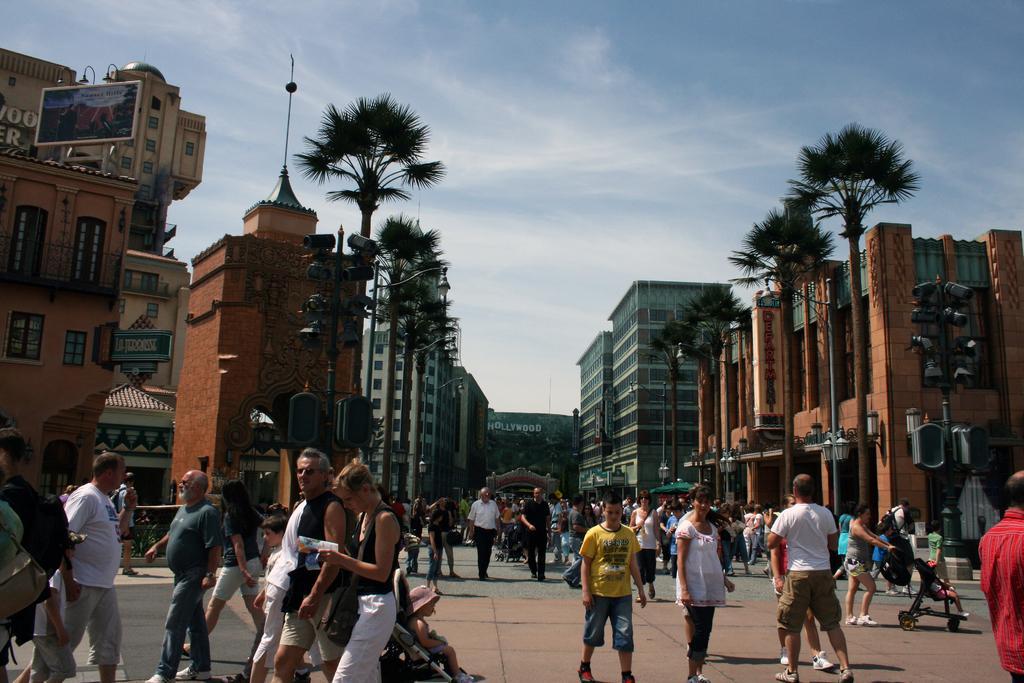In one or two sentences, can you explain what this image depicts? This picture is clicked outside and we can see the group of people seems to be walking on the ground and we can see the kids in the strollers. In the background we can see the sky, trees, lights attached to the metal rods and we can see the buildings, text attached to the buildings and we can see many other objects. 